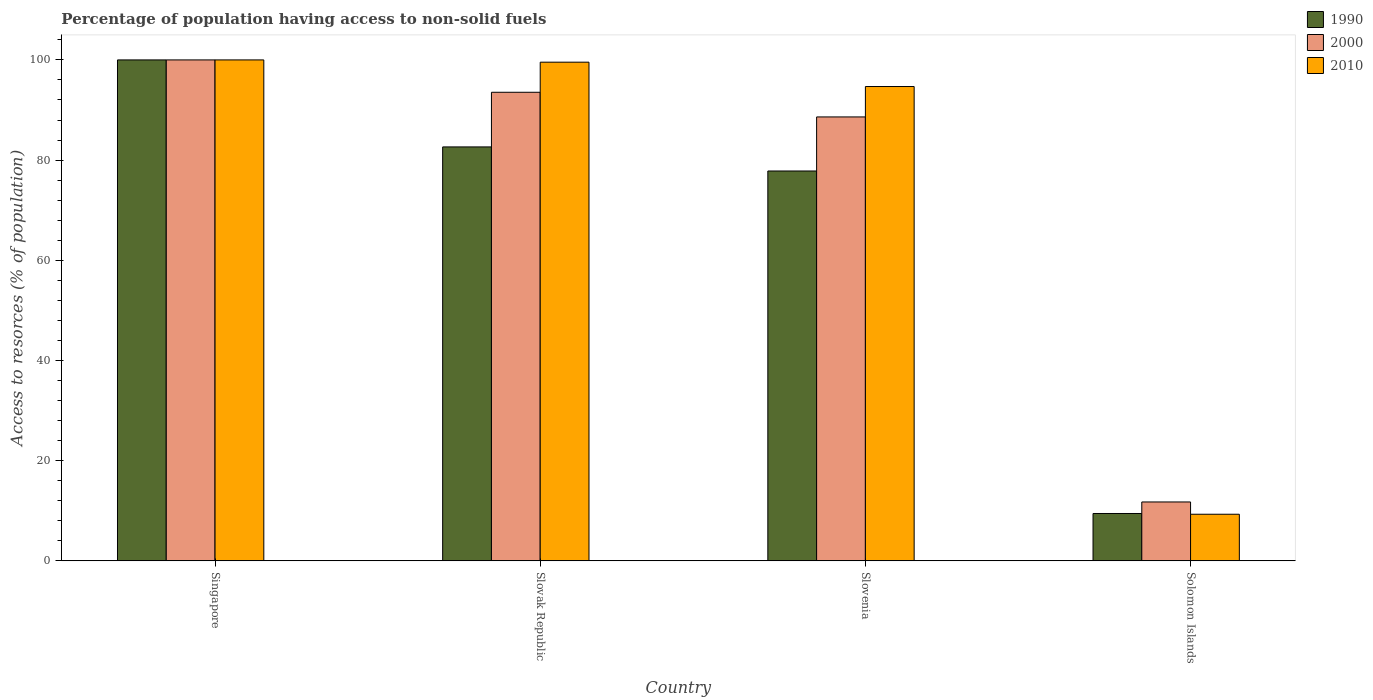How many different coloured bars are there?
Your response must be concise. 3. Are the number of bars on each tick of the X-axis equal?
Give a very brief answer. Yes. How many bars are there on the 3rd tick from the left?
Provide a succinct answer. 3. What is the label of the 3rd group of bars from the left?
Keep it short and to the point. Slovenia. In how many cases, is the number of bars for a given country not equal to the number of legend labels?
Your response must be concise. 0. What is the percentage of population having access to non-solid fuels in 1990 in Singapore?
Offer a terse response. 100. Across all countries, what is the minimum percentage of population having access to non-solid fuels in 2000?
Your answer should be very brief. 11.75. In which country was the percentage of population having access to non-solid fuels in 1990 maximum?
Ensure brevity in your answer.  Singapore. In which country was the percentage of population having access to non-solid fuels in 2000 minimum?
Make the answer very short. Solomon Islands. What is the total percentage of population having access to non-solid fuels in 2000 in the graph?
Your response must be concise. 293.91. What is the difference between the percentage of population having access to non-solid fuels in 1990 in Slovak Republic and that in Solomon Islands?
Offer a terse response. 73.18. What is the difference between the percentage of population having access to non-solid fuels in 2000 in Slovenia and the percentage of population having access to non-solid fuels in 1990 in Singapore?
Offer a very short reply. -11.38. What is the average percentage of population having access to non-solid fuels in 2000 per country?
Provide a short and direct response. 73.48. What is the difference between the percentage of population having access to non-solid fuels of/in 2000 and percentage of population having access to non-solid fuels of/in 2010 in Singapore?
Ensure brevity in your answer.  0. In how many countries, is the percentage of population having access to non-solid fuels in 2000 greater than 44 %?
Make the answer very short. 3. What is the ratio of the percentage of population having access to non-solid fuels in 2000 in Slovenia to that in Solomon Islands?
Provide a succinct answer. 7.54. What is the difference between the highest and the second highest percentage of population having access to non-solid fuels in 2000?
Provide a short and direct response. -11.38. What is the difference between the highest and the lowest percentage of population having access to non-solid fuels in 2010?
Your answer should be compact. 90.7. Is the sum of the percentage of population having access to non-solid fuels in 1990 in Slovak Republic and Solomon Islands greater than the maximum percentage of population having access to non-solid fuels in 2010 across all countries?
Provide a short and direct response. No. What does the 1st bar from the left in Singapore represents?
Your answer should be very brief. 1990. What does the 3rd bar from the right in Singapore represents?
Ensure brevity in your answer.  1990. Is it the case that in every country, the sum of the percentage of population having access to non-solid fuels in 2010 and percentage of population having access to non-solid fuels in 2000 is greater than the percentage of population having access to non-solid fuels in 1990?
Ensure brevity in your answer.  Yes. Are all the bars in the graph horizontal?
Your answer should be very brief. No. How many countries are there in the graph?
Give a very brief answer. 4. Are the values on the major ticks of Y-axis written in scientific E-notation?
Offer a very short reply. No. Where does the legend appear in the graph?
Your answer should be compact. Top right. How many legend labels are there?
Ensure brevity in your answer.  3. What is the title of the graph?
Offer a very short reply. Percentage of population having access to non-solid fuels. What is the label or title of the Y-axis?
Keep it short and to the point. Access to resorces (% of population). What is the Access to resorces (% of population) in 1990 in Singapore?
Give a very brief answer. 100. What is the Access to resorces (% of population) of 2010 in Singapore?
Your answer should be compact. 100. What is the Access to resorces (% of population) of 1990 in Slovak Republic?
Offer a very short reply. 82.63. What is the Access to resorces (% of population) of 2000 in Slovak Republic?
Provide a succinct answer. 93.54. What is the Access to resorces (% of population) of 2010 in Slovak Republic?
Your response must be concise. 99.55. What is the Access to resorces (% of population) in 1990 in Slovenia?
Provide a succinct answer. 77.82. What is the Access to resorces (% of population) of 2000 in Slovenia?
Your answer should be very brief. 88.62. What is the Access to resorces (% of population) in 2010 in Slovenia?
Offer a very short reply. 94.69. What is the Access to resorces (% of population) in 1990 in Solomon Islands?
Give a very brief answer. 9.45. What is the Access to resorces (% of population) of 2000 in Solomon Islands?
Your answer should be compact. 11.75. What is the Access to resorces (% of population) of 2010 in Solomon Islands?
Provide a short and direct response. 9.3. Across all countries, what is the minimum Access to resorces (% of population) of 1990?
Offer a terse response. 9.45. Across all countries, what is the minimum Access to resorces (% of population) of 2000?
Offer a very short reply. 11.75. Across all countries, what is the minimum Access to resorces (% of population) in 2010?
Your response must be concise. 9.3. What is the total Access to resorces (% of population) of 1990 in the graph?
Provide a succinct answer. 269.91. What is the total Access to resorces (% of population) in 2000 in the graph?
Provide a short and direct response. 293.91. What is the total Access to resorces (% of population) in 2010 in the graph?
Offer a terse response. 303.54. What is the difference between the Access to resorces (% of population) in 1990 in Singapore and that in Slovak Republic?
Your answer should be very brief. 17.37. What is the difference between the Access to resorces (% of population) of 2000 in Singapore and that in Slovak Republic?
Your answer should be compact. 6.46. What is the difference between the Access to resorces (% of population) in 2010 in Singapore and that in Slovak Republic?
Offer a very short reply. 0.45. What is the difference between the Access to resorces (% of population) in 1990 in Singapore and that in Slovenia?
Ensure brevity in your answer.  22.18. What is the difference between the Access to resorces (% of population) in 2000 in Singapore and that in Slovenia?
Keep it short and to the point. 11.38. What is the difference between the Access to resorces (% of population) in 2010 in Singapore and that in Slovenia?
Your answer should be compact. 5.31. What is the difference between the Access to resorces (% of population) in 1990 in Singapore and that in Solomon Islands?
Give a very brief answer. 90.55. What is the difference between the Access to resorces (% of population) in 2000 in Singapore and that in Solomon Islands?
Ensure brevity in your answer.  88.25. What is the difference between the Access to resorces (% of population) of 2010 in Singapore and that in Solomon Islands?
Make the answer very short. 90.7. What is the difference between the Access to resorces (% of population) of 1990 in Slovak Republic and that in Slovenia?
Your response must be concise. 4.81. What is the difference between the Access to resorces (% of population) in 2000 in Slovak Republic and that in Slovenia?
Provide a succinct answer. 4.92. What is the difference between the Access to resorces (% of population) in 2010 in Slovak Republic and that in Slovenia?
Provide a succinct answer. 4.86. What is the difference between the Access to resorces (% of population) of 1990 in Slovak Republic and that in Solomon Islands?
Your answer should be very brief. 73.18. What is the difference between the Access to resorces (% of population) in 2000 in Slovak Republic and that in Solomon Islands?
Your answer should be compact. 81.79. What is the difference between the Access to resorces (% of population) in 2010 in Slovak Republic and that in Solomon Islands?
Your response must be concise. 90.25. What is the difference between the Access to resorces (% of population) in 1990 in Slovenia and that in Solomon Islands?
Offer a terse response. 68.37. What is the difference between the Access to resorces (% of population) of 2000 in Slovenia and that in Solomon Islands?
Offer a very short reply. 76.87. What is the difference between the Access to resorces (% of population) of 2010 in Slovenia and that in Solomon Islands?
Provide a succinct answer. 85.39. What is the difference between the Access to resorces (% of population) of 1990 in Singapore and the Access to resorces (% of population) of 2000 in Slovak Republic?
Offer a very short reply. 6.46. What is the difference between the Access to resorces (% of population) of 1990 in Singapore and the Access to resorces (% of population) of 2010 in Slovak Republic?
Offer a terse response. 0.45. What is the difference between the Access to resorces (% of population) in 2000 in Singapore and the Access to resorces (% of population) in 2010 in Slovak Republic?
Provide a short and direct response. 0.45. What is the difference between the Access to resorces (% of population) in 1990 in Singapore and the Access to resorces (% of population) in 2000 in Slovenia?
Ensure brevity in your answer.  11.38. What is the difference between the Access to resorces (% of population) of 1990 in Singapore and the Access to resorces (% of population) of 2010 in Slovenia?
Your answer should be very brief. 5.31. What is the difference between the Access to resorces (% of population) in 2000 in Singapore and the Access to resorces (% of population) in 2010 in Slovenia?
Your answer should be compact. 5.31. What is the difference between the Access to resorces (% of population) of 1990 in Singapore and the Access to resorces (% of population) of 2000 in Solomon Islands?
Your answer should be very brief. 88.25. What is the difference between the Access to resorces (% of population) of 1990 in Singapore and the Access to resorces (% of population) of 2010 in Solomon Islands?
Offer a very short reply. 90.7. What is the difference between the Access to resorces (% of population) of 2000 in Singapore and the Access to resorces (% of population) of 2010 in Solomon Islands?
Offer a very short reply. 90.7. What is the difference between the Access to resorces (% of population) of 1990 in Slovak Republic and the Access to resorces (% of population) of 2000 in Slovenia?
Ensure brevity in your answer.  -5.99. What is the difference between the Access to resorces (% of population) in 1990 in Slovak Republic and the Access to resorces (% of population) in 2010 in Slovenia?
Offer a terse response. -12.05. What is the difference between the Access to resorces (% of population) in 2000 in Slovak Republic and the Access to resorces (% of population) in 2010 in Slovenia?
Make the answer very short. -1.15. What is the difference between the Access to resorces (% of population) of 1990 in Slovak Republic and the Access to resorces (% of population) of 2000 in Solomon Islands?
Your response must be concise. 70.88. What is the difference between the Access to resorces (% of population) in 1990 in Slovak Republic and the Access to resorces (% of population) in 2010 in Solomon Islands?
Provide a succinct answer. 73.33. What is the difference between the Access to resorces (% of population) in 2000 in Slovak Republic and the Access to resorces (% of population) in 2010 in Solomon Islands?
Your answer should be very brief. 84.24. What is the difference between the Access to resorces (% of population) in 1990 in Slovenia and the Access to resorces (% of population) in 2000 in Solomon Islands?
Your response must be concise. 66.07. What is the difference between the Access to resorces (% of population) of 1990 in Slovenia and the Access to resorces (% of population) of 2010 in Solomon Islands?
Ensure brevity in your answer.  68.52. What is the difference between the Access to resorces (% of population) of 2000 in Slovenia and the Access to resorces (% of population) of 2010 in Solomon Islands?
Offer a very short reply. 79.32. What is the average Access to resorces (% of population) of 1990 per country?
Provide a short and direct response. 67.48. What is the average Access to resorces (% of population) in 2000 per country?
Offer a very short reply. 73.48. What is the average Access to resorces (% of population) in 2010 per country?
Give a very brief answer. 75.88. What is the difference between the Access to resorces (% of population) in 1990 and Access to resorces (% of population) in 2000 in Singapore?
Keep it short and to the point. 0. What is the difference between the Access to resorces (% of population) of 1990 and Access to resorces (% of population) of 2010 in Singapore?
Provide a succinct answer. 0. What is the difference between the Access to resorces (% of population) in 2000 and Access to resorces (% of population) in 2010 in Singapore?
Keep it short and to the point. 0. What is the difference between the Access to resorces (% of population) of 1990 and Access to resorces (% of population) of 2000 in Slovak Republic?
Give a very brief answer. -10.91. What is the difference between the Access to resorces (% of population) in 1990 and Access to resorces (% of population) in 2010 in Slovak Republic?
Make the answer very short. -16.91. What is the difference between the Access to resorces (% of population) of 2000 and Access to resorces (% of population) of 2010 in Slovak Republic?
Your answer should be compact. -6.01. What is the difference between the Access to resorces (% of population) of 1990 and Access to resorces (% of population) of 2000 in Slovenia?
Your answer should be very brief. -10.79. What is the difference between the Access to resorces (% of population) in 1990 and Access to resorces (% of population) in 2010 in Slovenia?
Ensure brevity in your answer.  -16.86. What is the difference between the Access to resorces (% of population) in 2000 and Access to resorces (% of population) in 2010 in Slovenia?
Keep it short and to the point. -6.07. What is the difference between the Access to resorces (% of population) of 1990 and Access to resorces (% of population) of 2000 in Solomon Islands?
Keep it short and to the point. -2.3. What is the difference between the Access to resorces (% of population) in 1990 and Access to resorces (% of population) in 2010 in Solomon Islands?
Provide a short and direct response. 0.15. What is the difference between the Access to resorces (% of population) of 2000 and Access to resorces (% of population) of 2010 in Solomon Islands?
Ensure brevity in your answer.  2.45. What is the ratio of the Access to resorces (% of population) in 1990 in Singapore to that in Slovak Republic?
Your response must be concise. 1.21. What is the ratio of the Access to resorces (% of population) in 2000 in Singapore to that in Slovak Republic?
Your response must be concise. 1.07. What is the ratio of the Access to resorces (% of population) in 1990 in Singapore to that in Slovenia?
Give a very brief answer. 1.28. What is the ratio of the Access to resorces (% of population) in 2000 in Singapore to that in Slovenia?
Your answer should be very brief. 1.13. What is the ratio of the Access to resorces (% of population) in 2010 in Singapore to that in Slovenia?
Offer a terse response. 1.06. What is the ratio of the Access to resorces (% of population) in 1990 in Singapore to that in Solomon Islands?
Your response must be concise. 10.58. What is the ratio of the Access to resorces (% of population) of 2000 in Singapore to that in Solomon Islands?
Provide a succinct answer. 8.51. What is the ratio of the Access to resorces (% of population) of 2010 in Singapore to that in Solomon Islands?
Offer a terse response. 10.75. What is the ratio of the Access to resorces (% of population) of 1990 in Slovak Republic to that in Slovenia?
Ensure brevity in your answer.  1.06. What is the ratio of the Access to resorces (% of population) in 2000 in Slovak Republic to that in Slovenia?
Your answer should be very brief. 1.06. What is the ratio of the Access to resorces (% of population) of 2010 in Slovak Republic to that in Slovenia?
Keep it short and to the point. 1.05. What is the ratio of the Access to resorces (% of population) of 1990 in Slovak Republic to that in Solomon Islands?
Make the answer very short. 8.74. What is the ratio of the Access to resorces (% of population) in 2000 in Slovak Republic to that in Solomon Islands?
Your answer should be compact. 7.96. What is the ratio of the Access to resorces (% of population) of 2010 in Slovak Republic to that in Solomon Islands?
Make the answer very short. 10.7. What is the ratio of the Access to resorces (% of population) in 1990 in Slovenia to that in Solomon Islands?
Ensure brevity in your answer.  8.24. What is the ratio of the Access to resorces (% of population) of 2000 in Slovenia to that in Solomon Islands?
Give a very brief answer. 7.54. What is the ratio of the Access to resorces (% of population) of 2010 in Slovenia to that in Solomon Islands?
Offer a terse response. 10.18. What is the difference between the highest and the second highest Access to resorces (% of population) in 1990?
Provide a succinct answer. 17.37. What is the difference between the highest and the second highest Access to resorces (% of population) in 2000?
Offer a terse response. 6.46. What is the difference between the highest and the second highest Access to resorces (% of population) in 2010?
Offer a terse response. 0.45. What is the difference between the highest and the lowest Access to resorces (% of population) of 1990?
Offer a terse response. 90.55. What is the difference between the highest and the lowest Access to resorces (% of population) of 2000?
Offer a very short reply. 88.25. What is the difference between the highest and the lowest Access to resorces (% of population) in 2010?
Your answer should be compact. 90.7. 